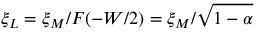<formula> <loc_0><loc_0><loc_500><loc_500>\xi _ { L } = \xi _ { M } / F ( - W / 2 ) = \xi _ { M } / \sqrt { 1 - \alpha }</formula> 